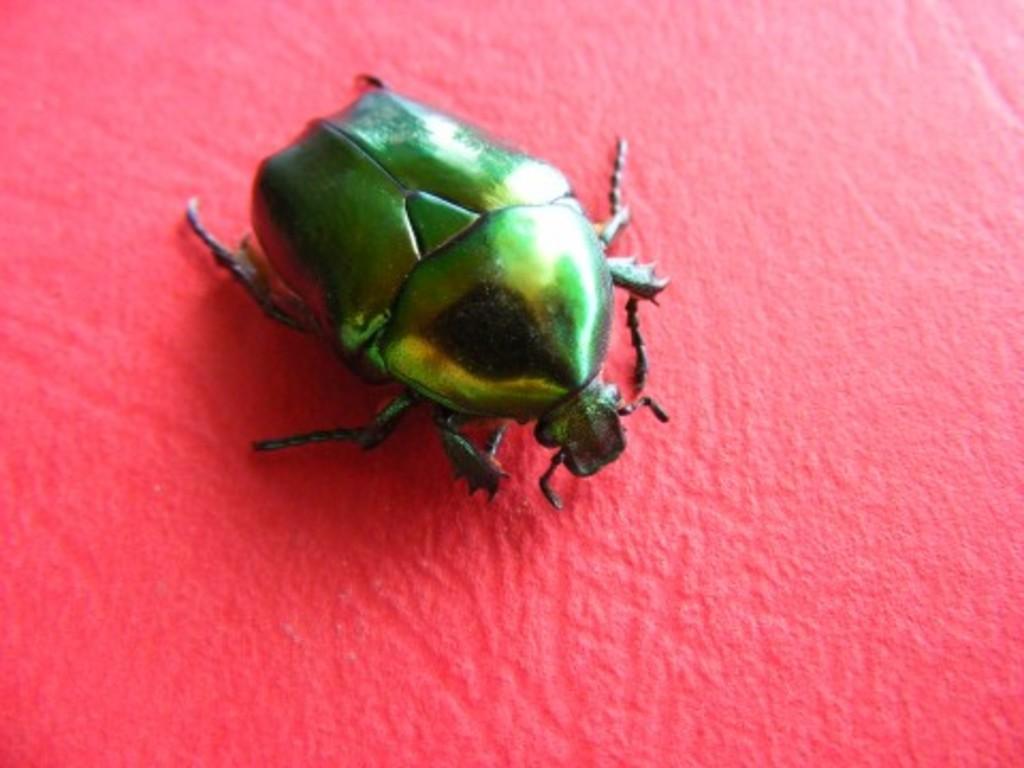In one or two sentences, can you explain what this image depicts? In this picture I can see there is a bug on a pink surface and it has a body, head and legs. 